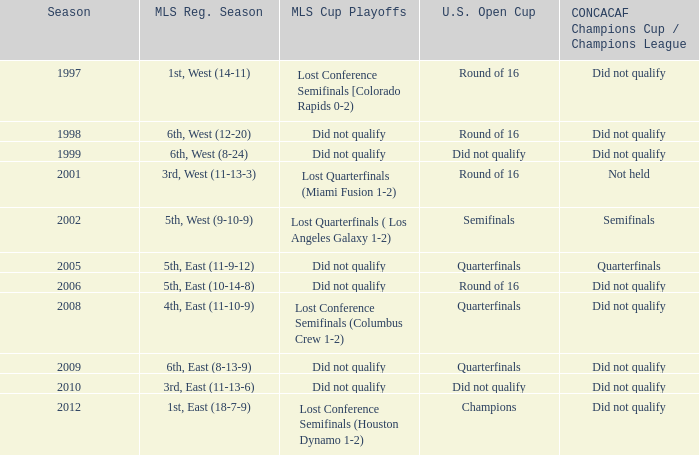Could you parse the entire table as a dict? {'header': ['Season', 'MLS Reg. Season', 'MLS Cup Playoffs', 'U.S. Open Cup', 'CONCACAF Champions Cup / Champions League'], 'rows': [['1997', '1st, West (14-11)', 'Lost Conference Semifinals [Colorado Rapids 0-2)', 'Round of 16', 'Did not qualify'], ['1998', '6th, West (12-20)', 'Did not qualify', 'Round of 16', 'Did not qualify'], ['1999', '6th, West (8-24)', 'Did not qualify', 'Did not qualify', 'Did not qualify'], ['2001', '3rd, West (11-13-3)', 'Lost Quarterfinals (Miami Fusion 1-2)', 'Round of 16', 'Not held'], ['2002', '5th, West (9-10-9)', 'Lost Quarterfinals ( Los Angeles Galaxy 1-2)', 'Semifinals', 'Semifinals'], ['2005', '5th, East (11-9-12)', 'Did not qualify', 'Quarterfinals', 'Quarterfinals'], ['2006', '5th, East (10-14-8)', 'Did not qualify', 'Round of 16', 'Did not qualify'], ['2008', '4th, East (11-10-9)', 'Lost Conference Semifinals (Columbus Crew 1-2)', 'Quarterfinals', 'Did not qualify'], ['2009', '6th, East (8-13-9)', 'Did not qualify', 'Quarterfinals', 'Did not qualify'], ['2010', '3rd, East (11-13-6)', 'Did not qualify', 'Did not qualify', 'Did not qualify'], ['2012', '1st, East (18-7-9)', 'Lost Conference Semifinals (Houston Dynamo 1-2)', 'Champions', 'Did not qualify']]} When the team reached the u.s. open cup quarterfinals but did not qualify for the concaf champions cup, what were their regular season standings? 4th, East (11-10-9), 6th, East (8-13-9). 